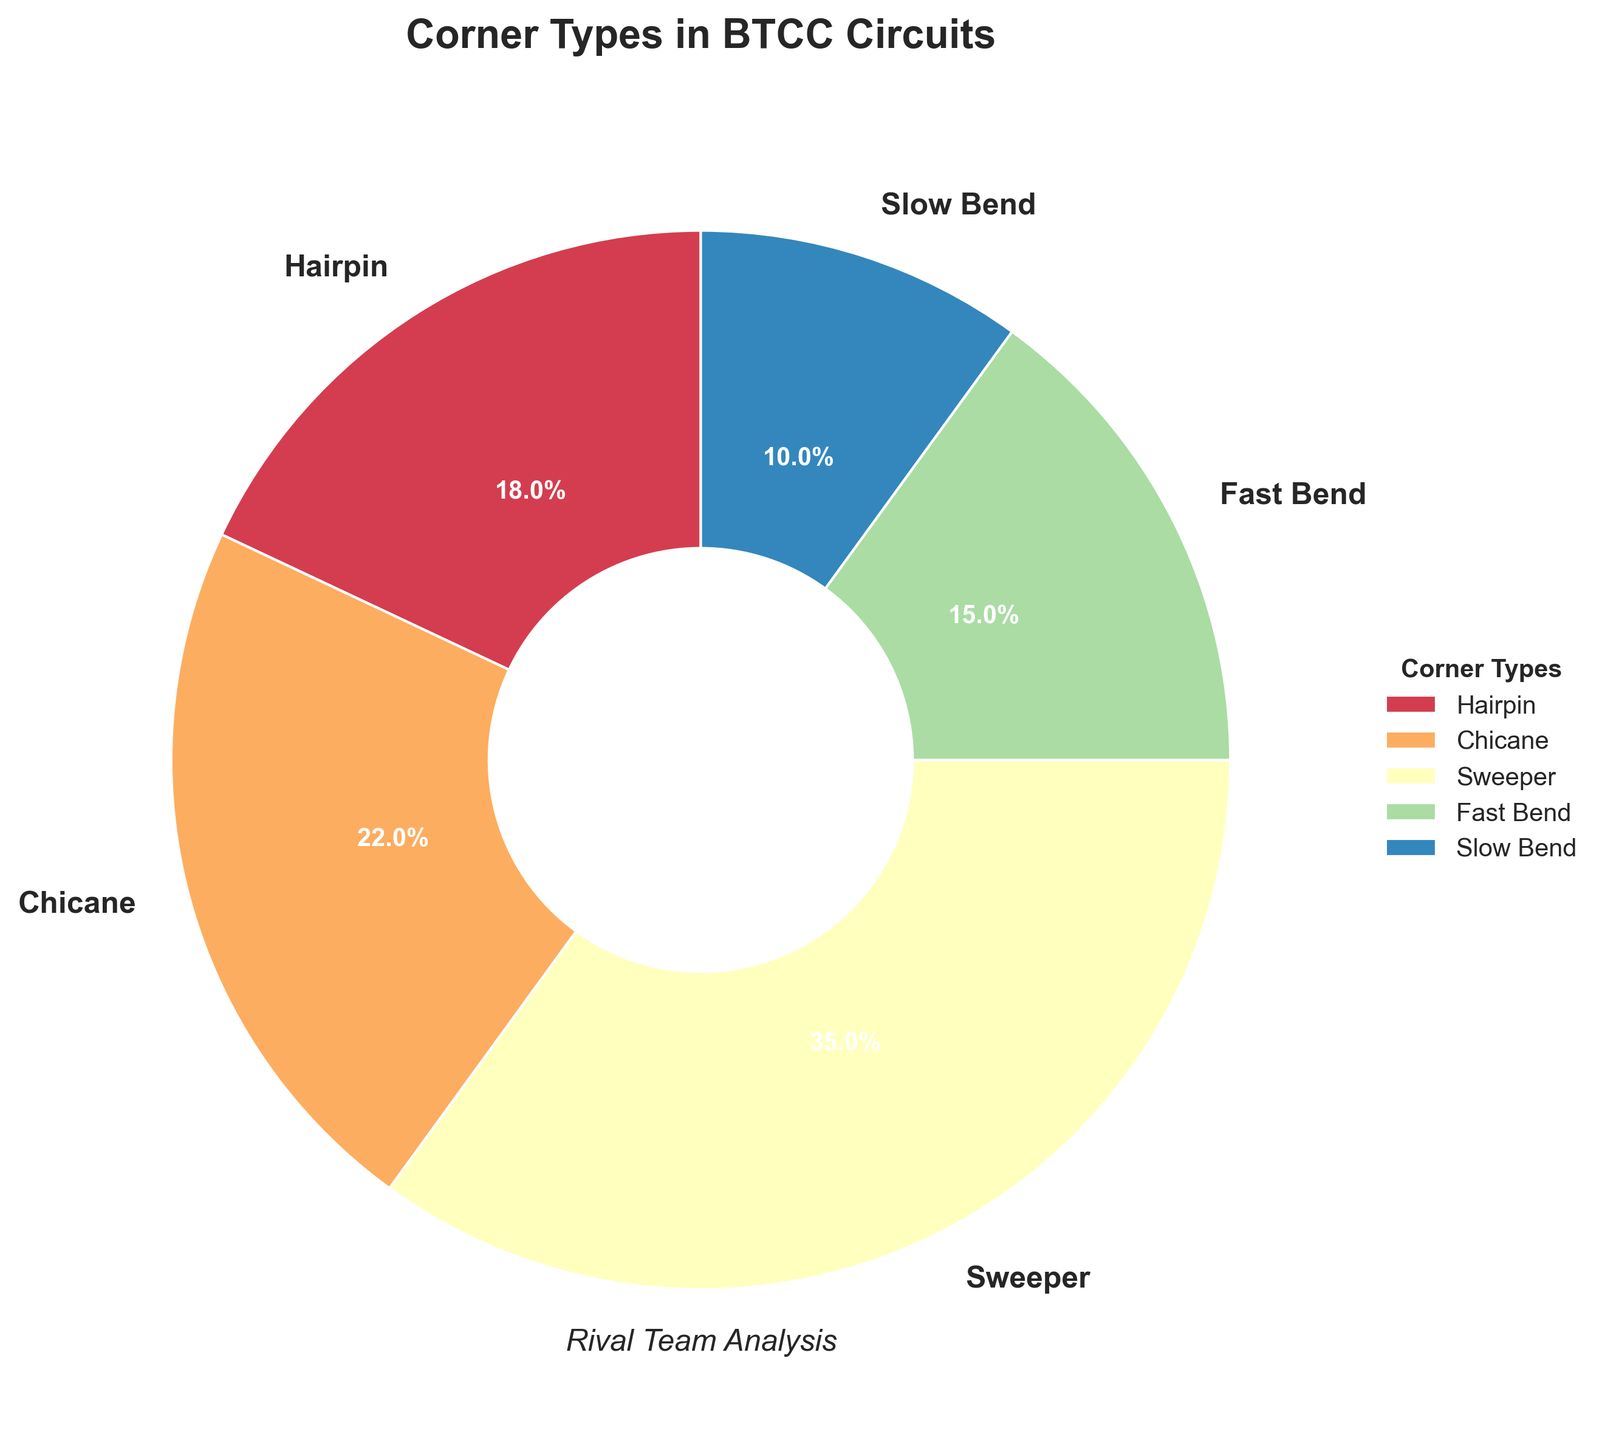Which type of corner is most common in BTCC circuits? By looking at the pie chart, Sweeper has the largest section, which indicates it has the highest percentage among all the corner types.
Answer: Sweeper How much more common are chicanes compared to slow bends? According to the pie chart, chicanes have a percentage of 22%, while slow bends have 10%. The difference between them is 22% - 10% = 12%.
Answer: 12% What percentage of corners are either hairpins or fast bends? By looking at the pie chart, hairpins have 18% and fast bends have 15%. Adding these together gives 18% + 15% = 33%.
Answer: 33% Which corner type occupies the smallest portion of the pie chart? The smallest section in the pie chart corresponds to Slow Bend, with a percentage of 10%.
Answer: Slow Bend What is the combined percentage of all the corners except for sweepers? The pie chart shows the percentage for hairpins (18%), chicanes (22%), fast bends (15%), and slow bends (10%). Adding these gives 18% + 22% + 15% + 10% = 65%.
Answer: 65% Does the percentage of chicanes exceed the percentage of hairpins? Yes, the pie chart shows 22% for chicanes and 18% for hairpins. Since 22% is greater than 18%, chicanes exceed hairpins.
Answer: Yes What is the difference in percentage points between the most and least common corner types? The most common corner type (Sweeper) has 35%, and the least common corner type (Slow Bend) has 10%. The difference is 35% - 10% = 25%.
Answer: 25% Which corner types together form more than half of the total corners? The pie chart shows the percentages for sweepers (35%) and chicanes (22%). Adding these together gives 35% + 22% = 57%, which is more than half (50%).
Answer: Sweepers and Chicanes If you were to add the percentage of fast bends and slow bends together, would it be more or less than the percentage of sweepers? Fast bends have 15% and slow bends have 10%. Together, this is 15% + 10% = 25%. Since 25% is less than 35% (the percentage for sweepers), it is less.
Answer: Less 